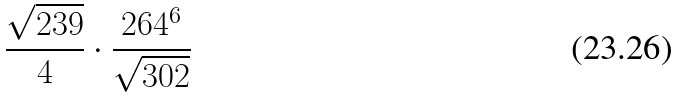<formula> <loc_0><loc_0><loc_500><loc_500>\frac { \sqrt { 2 3 9 } } { 4 } \cdot \frac { 2 6 4 ^ { 6 } } { \sqrt { 3 0 2 } }</formula> 